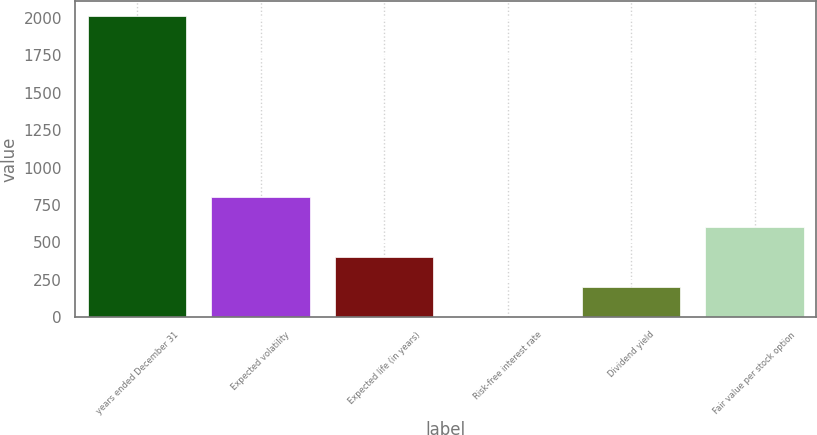Convert chart to OTSL. <chart><loc_0><loc_0><loc_500><loc_500><bar_chart><fcel>years ended December 31<fcel>Expected volatility<fcel>Expected life (in years)<fcel>Risk-free interest rate<fcel>Dividend yield<fcel>Fair value per stock option<nl><fcel>2012<fcel>805.4<fcel>403.2<fcel>1<fcel>202.1<fcel>604.3<nl></chart> 